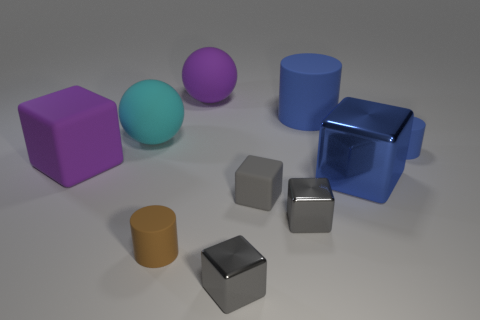There is a purple sphere that is made of the same material as the big cyan object; what size is it?
Ensure brevity in your answer.  Large. How many shiny cubes are the same color as the big matte block?
Your response must be concise. 0. What number of big things are matte balls or gray rubber objects?
Your answer should be compact. 2. What is the size of the other cylinder that is the same color as the large cylinder?
Offer a terse response. Small. Is there a tiny brown thing that has the same material as the large purple ball?
Your answer should be very brief. Yes. There is a large blue thing behind the tiny blue cylinder; what is it made of?
Your answer should be compact. Rubber. There is a ball that is in front of the purple ball; is it the same color as the small shiny cube that is in front of the small brown cylinder?
Offer a very short reply. No. What is the color of the matte cube that is the same size as the cyan sphere?
Your response must be concise. Purple. How many other objects are the same shape as the cyan rubber object?
Make the answer very short. 1. What size is the blue cylinder that is behind the small blue rubber cylinder?
Give a very brief answer. Large. 